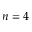Convert formula to latex. <formula><loc_0><loc_0><loc_500><loc_500>n = 4</formula> 